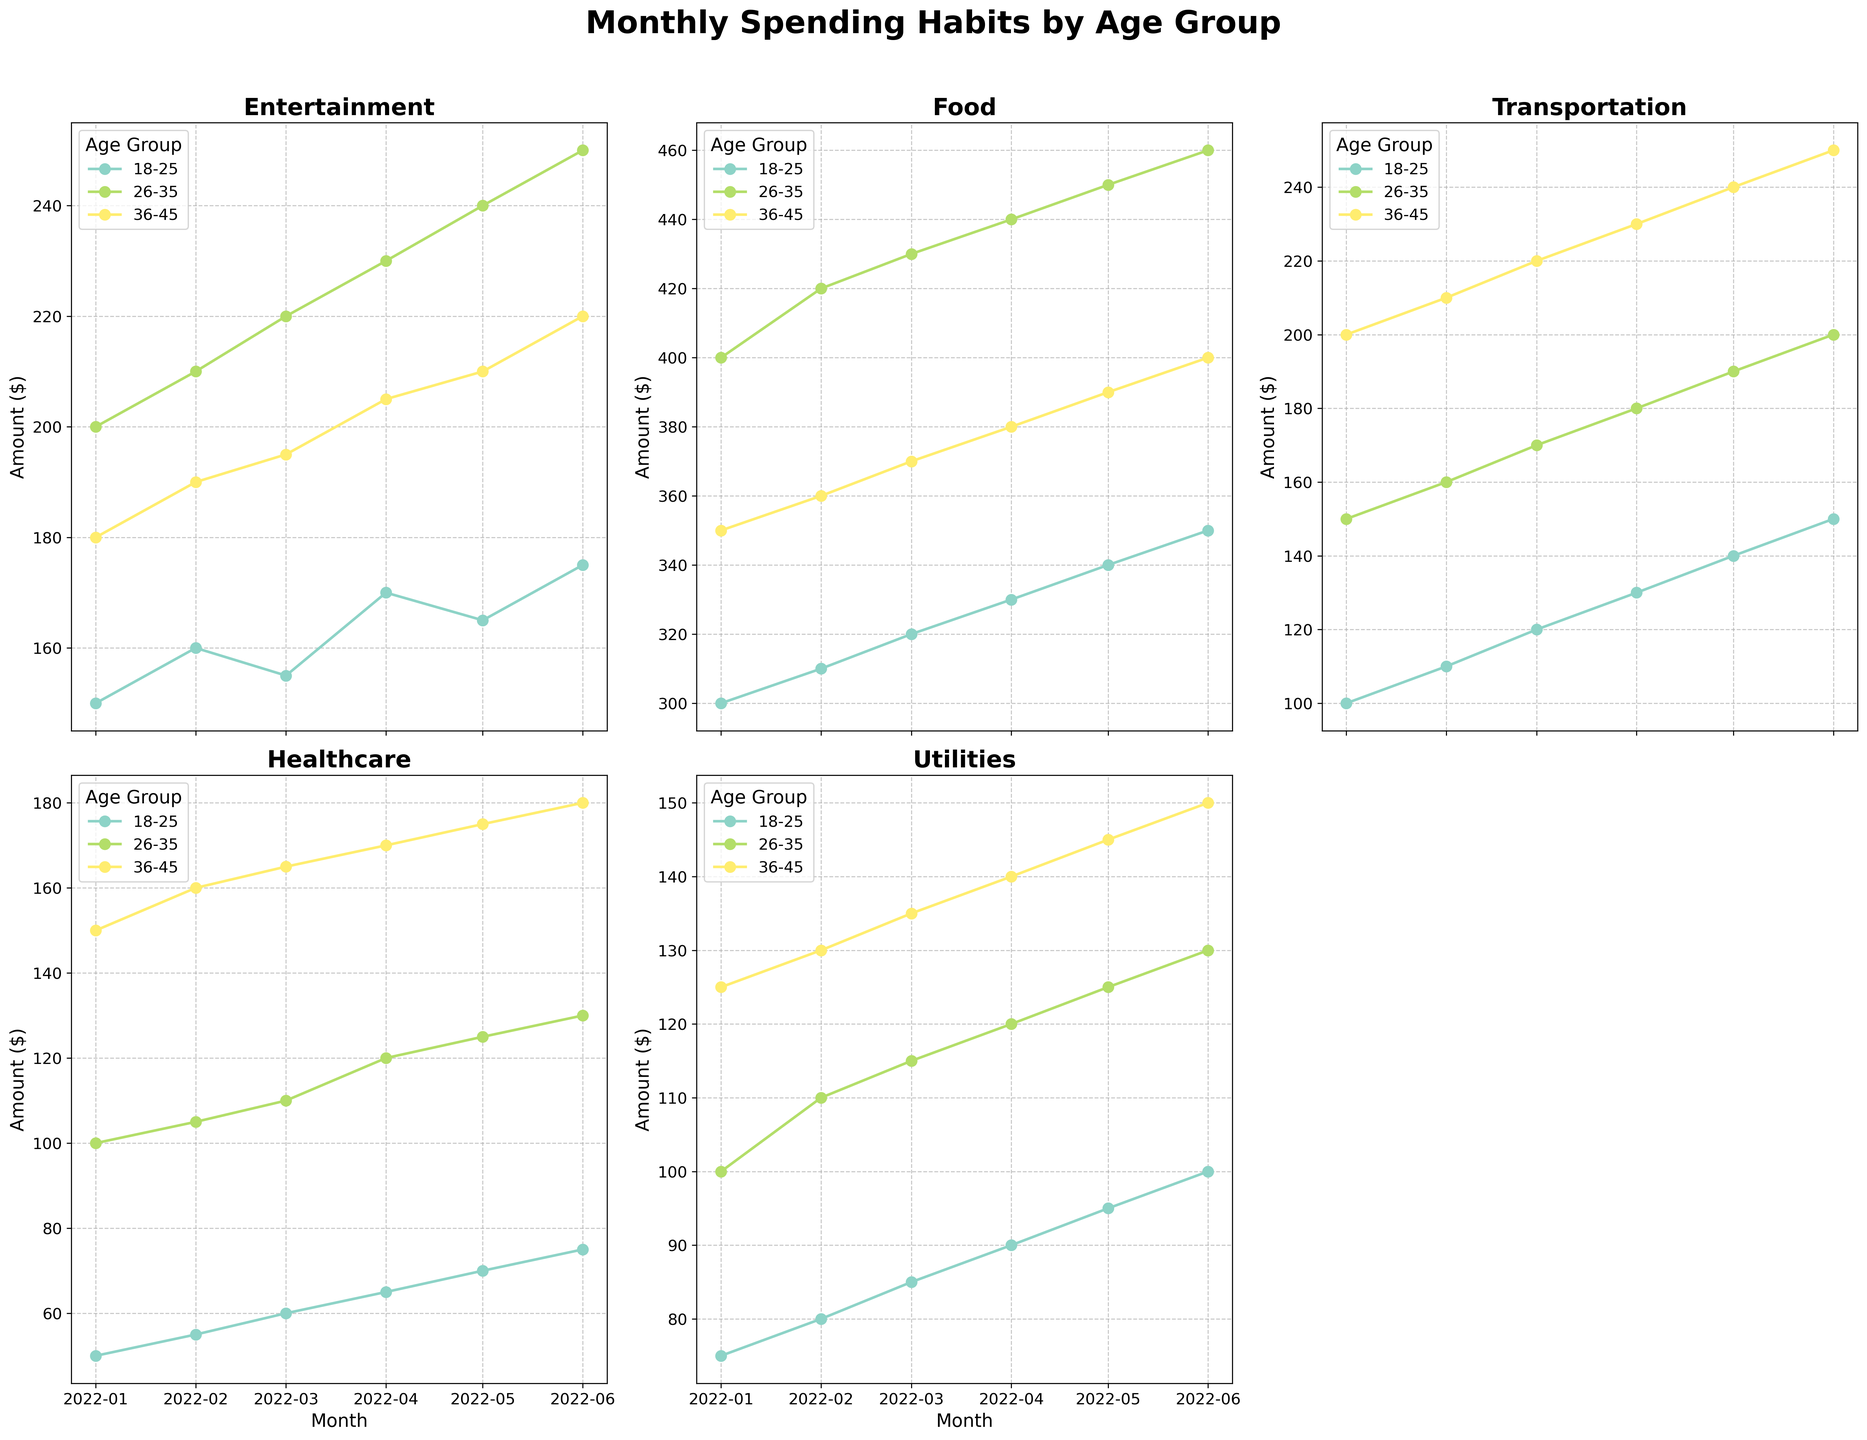What is the title of the figure? The title of the figure is usually found at the top-center of the plot. For this plot, it's "Monthly Spending Habits by Age Group."
Answer: Monthly Spending Habits by Age Group Which age group spends the most on entertainment in June 2022? To find this, look at the "Entertainment" subplot and locate the data points for June 2022. The 26-35 age group has the highest spending at $250.
Answer: 26-35 What's the trend in healthcare spending for the age group 36-45 from January to June 2022? Examine the "Healthcare" subplot and follow the line for the 36-45 age group from January to June. The plot shows a steady increase each month.
Answer: Steady increase What is the average food expenditure for the age group 18-25 from January to June 2022? Refer to the "Food" subplot and find the monthly data points for the 18-25 age group. Add those values (300, 310, 320, 330, 340, 350) and divide by 6. The calculation is (300 + 310 + 320 + 330 + 340 + 350)/6 = 325.
Answer: 325 Which category had the least variation in spending for the age group 26-35 between January and June 2022? Analyze each subplot for the age group 26-35. Look for the smallest range (difference between the highest and lowest values). The "Utilities" category has the least variation, ranging from $100 to $130.
Answer: Utilities How many months showed an increasing trend in transportation spending for the 18-25 age group from January to June 2022? Focus on the "Transportation" subplot and trace the line for 18-25. The spending increases in January, February, and March, demonstrating 3 months of increasing values.
Answer: 3 months Which age group has the highest overall spending on transportation in March 2022? Look at the "Transportation" subplot for March 2022. The age group 36-45 has the highest spending at $220.
Answer: 36-45 Is the spending on utilities for the age group 36-45 higher in June 2022 than January 2022? Refer to the "Utilities" subplot and compare the data points for January and June for the 36-45 age group. In June, it's $150, and in January, it's $125.
Answer: Yes What was the difference in food spending for the age group 26-35 between February and March 2022? On the "Food" subplot, find the data points for the age group 26-35 in February ($420) and March ($430). The difference is $430 - $420 = $10.
Answer: $10 Which month shows the highest entertainment spending for the age group 18-25? In the "Entertainment" subplot, track the spending for age group 18-25 across all months. April shows the highest spending at $170.
Answer: April 